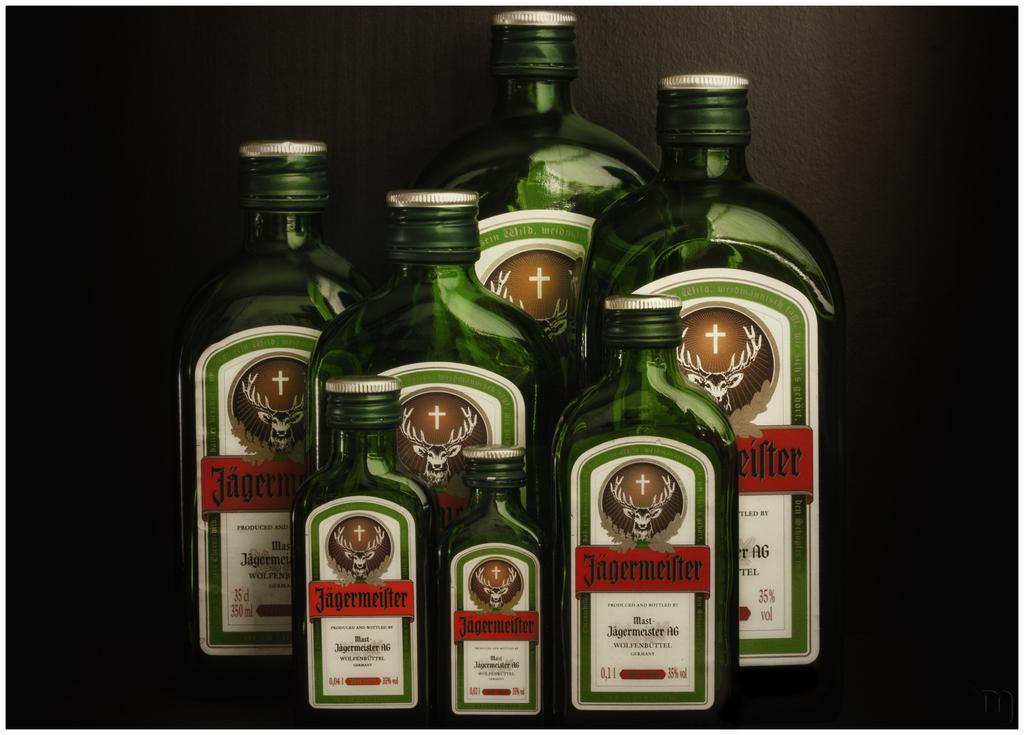<image>
Present a compact description of the photo's key features. seven bottles of jagermeifter standing in a group 